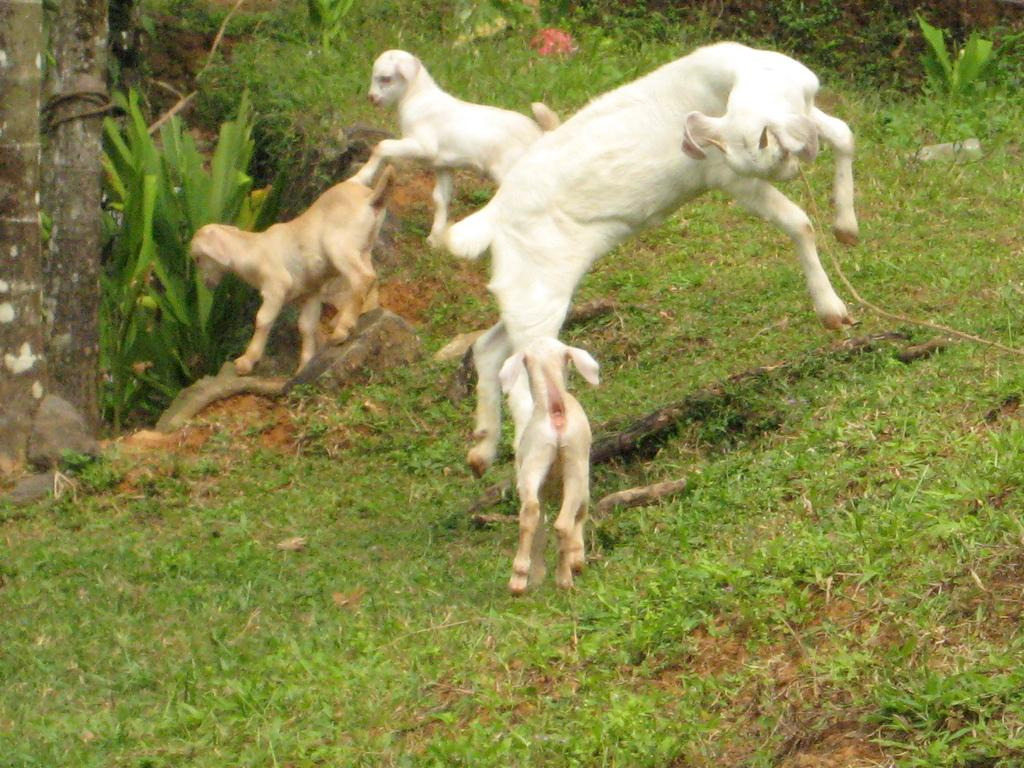What type of living organisms can be seen in the image? There are animals in the image. Where are the animals located in the image? The animals are on the ground in the image. What type of vegetation is visible in the image? There is grass and plants visible in the image. How many feet does the animal with the fang have in the image? There is no animal with a fang present in the image, and therefore no such detail can be observed. 